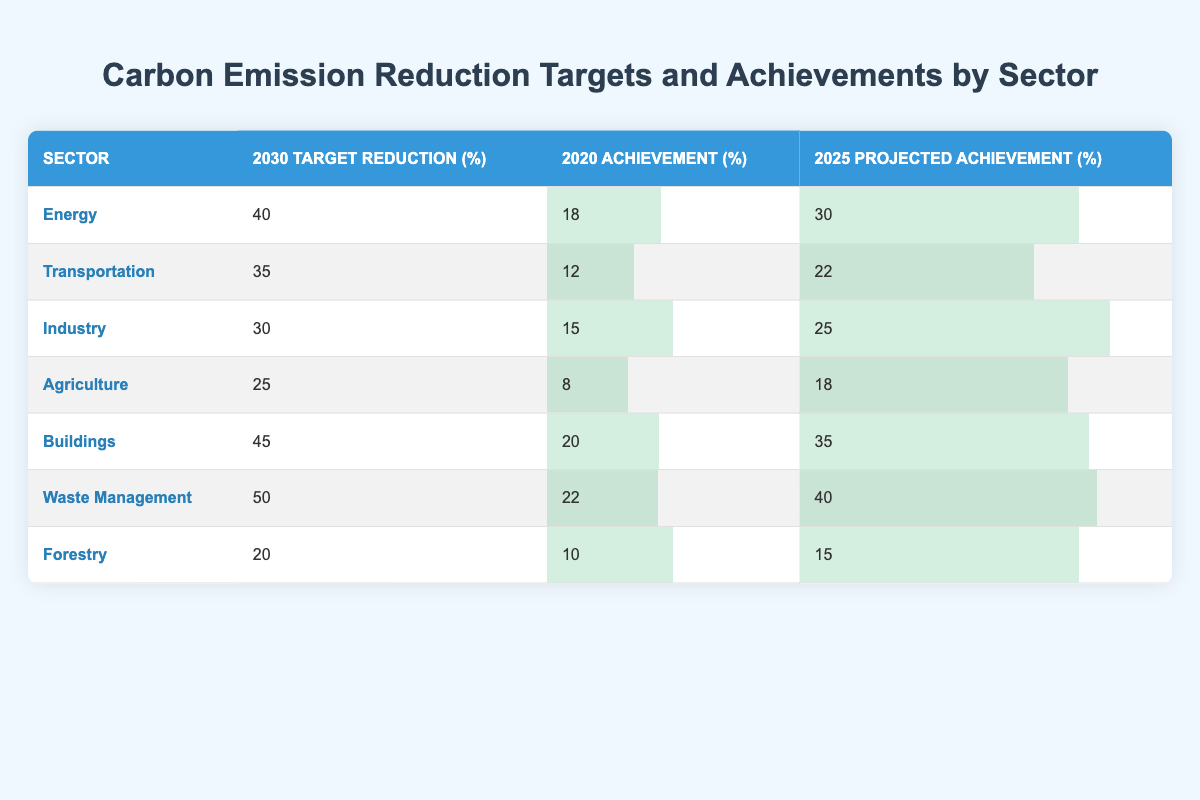What is the 2030 target reduction percentage for the Energy sector? According to the table, the Energy sector has a 2030 target reduction of 40%.
Answer: 40% Which sector has the highest 2025 projected achievement percentage? By reviewing the 2025 projected achievement column, the Waste Management sector has the highest achievement at 40%.
Answer: Waste Management What is the difference between the 2030 target reduction and the 2020 achievement for the Agriculture sector? The target reduction for Agriculture is 25%, while the achievement in 2020 is 8%. The difference is 25 - 8 = 17%.
Answer: 17% Is it true that the Transportation sector's 2020 achievement is above 10%? The table shows that the Transportation sector achieved 12% in 2020, which is indeed above 10%.
Answer: Yes What is the average 2020 achievement percentage across all sectors? First, sum the 2020 achievements: 18 + 12 + 15 + 8 + 20 + 22 + 10 = 105. There are 7 sectors, so the average is 105 / 7 = 15%.
Answer: 15% Which sector's 2025 projected achievement percentage is closest to its 2030 target reduction percentage? From the table, the Industry sector's 2030 target reduction is 30% and its 2025 projected achievement is 25%, which is closest when comparing the differences across all sectors.
Answer: Industry 